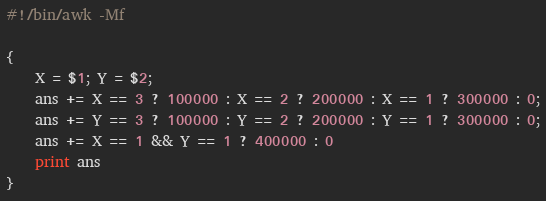<code> <loc_0><loc_0><loc_500><loc_500><_Awk_>#!/bin/awk -Mf

{
    X = $1; Y = $2;
    ans += X == 3 ? 100000 : X == 2 ? 200000 : X == 1 ? 300000 : 0;
    ans += Y == 3 ? 100000 : Y == 2 ? 200000 : Y == 1 ? 300000 : 0;
    ans += X == 1 && Y == 1 ? 400000 : 0
    print ans
}
</code> 